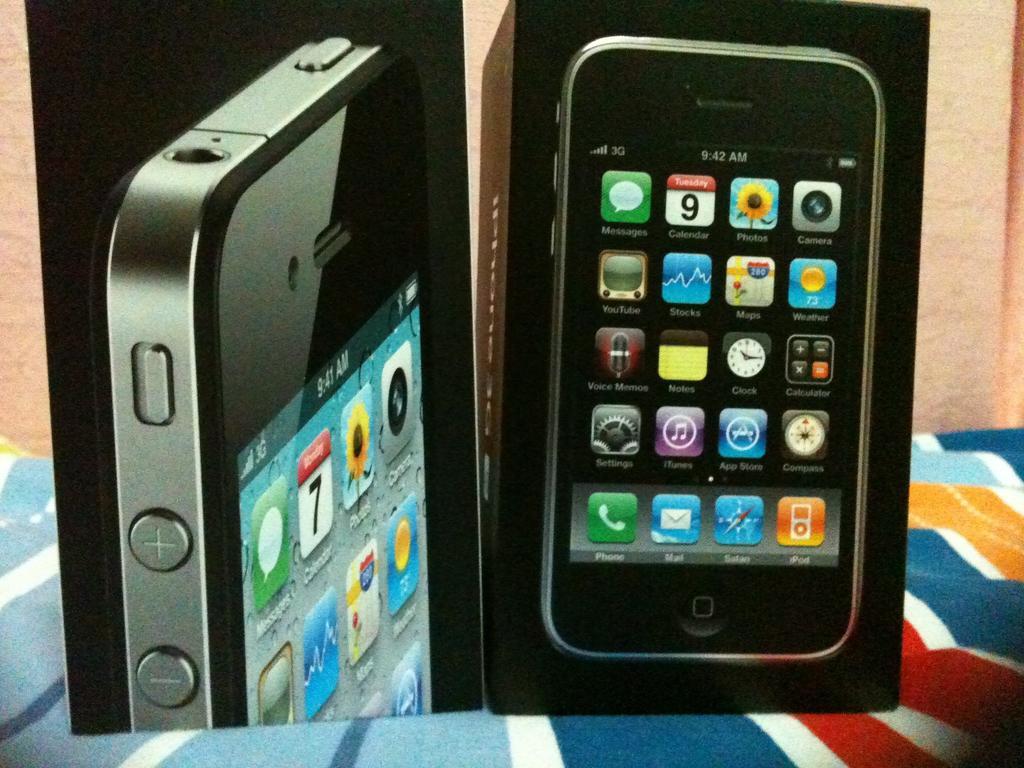In one or two sentences, can you explain what this image depicts? In this picture I can see boxes of mobiles on an object. 